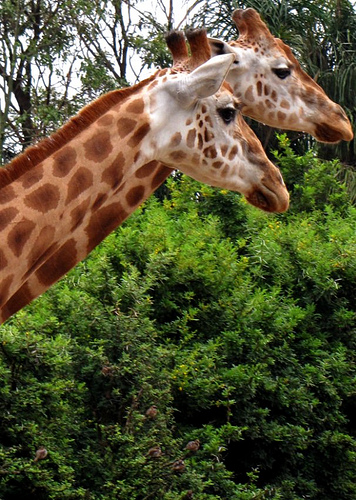<image>
Is the giraffe on the giraffe? No. The giraffe is not positioned on the giraffe. They may be near each other, but the giraffe is not supported by or resting on top of the giraffe. Where is the giraffe in relation to the giraffe? Is it in front of the giraffe? Yes. The giraffe is positioned in front of the giraffe, appearing closer to the camera viewpoint. 